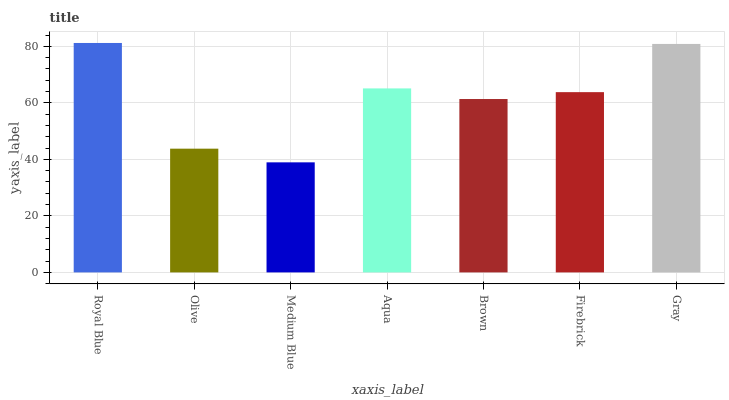Is Medium Blue the minimum?
Answer yes or no. Yes. Is Royal Blue the maximum?
Answer yes or no. Yes. Is Olive the minimum?
Answer yes or no. No. Is Olive the maximum?
Answer yes or no. No. Is Royal Blue greater than Olive?
Answer yes or no. Yes. Is Olive less than Royal Blue?
Answer yes or no. Yes. Is Olive greater than Royal Blue?
Answer yes or no. No. Is Royal Blue less than Olive?
Answer yes or no. No. Is Firebrick the high median?
Answer yes or no. Yes. Is Firebrick the low median?
Answer yes or no. Yes. Is Medium Blue the high median?
Answer yes or no. No. Is Medium Blue the low median?
Answer yes or no. No. 